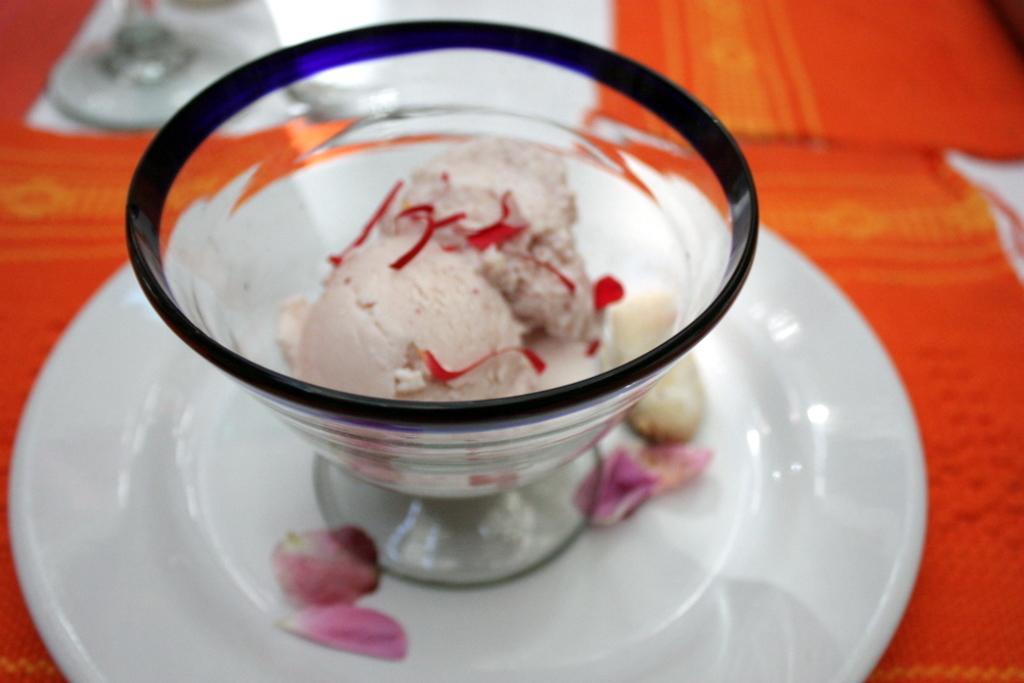Please provide a concise description of this image. In this image we can see a scoop of an ice cream in a cup places on a saucer. We can also see some petals of rose on a saucer. 